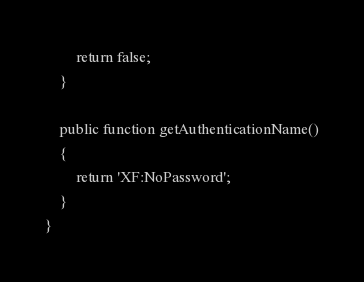Convert code to text. <code><loc_0><loc_0><loc_500><loc_500><_PHP_>		return false;
	}

	public function getAuthenticationName()
	{
		return 'XF:NoPassword';
	}
}</code> 